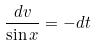<formula> <loc_0><loc_0><loc_500><loc_500>\frac { d v } { \sin x } = - d t</formula> 